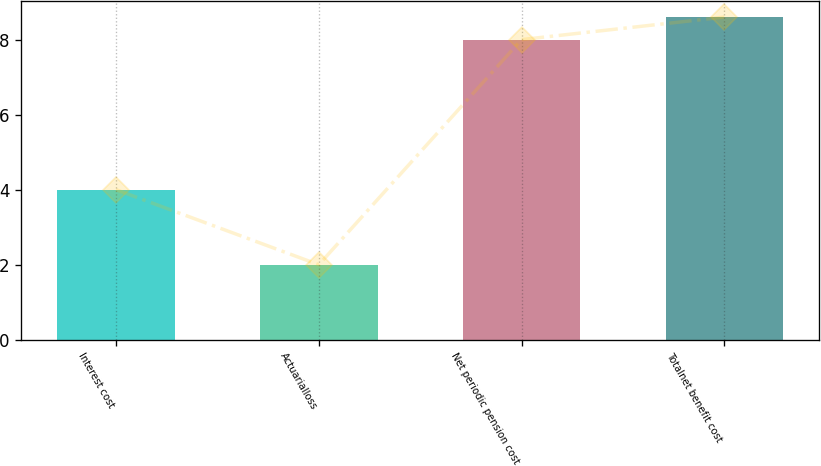Convert chart to OTSL. <chart><loc_0><loc_0><loc_500><loc_500><bar_chart><fcel>Interest cost<fcel>Actuarialloss<fcel>Net periodic pension cost<fcel>Totalnet benefit cost<nl><fcel>4<fcel>2<fcel>8<fcel>8.6<nl></chart> 